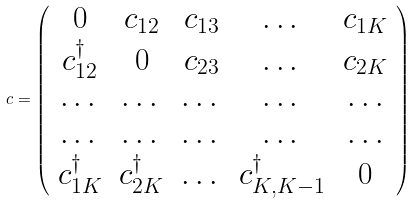<formula> <loc_0><loc_0><loc_500><loc_500>c = \left ( \begin{array} { c c c c c } 0 & c _ { 1 2 } & c _ { 1 3 } & \dots & c _ { 1 K } \\ c ^ { \dagger } _ { 1 2 } & 0 & c _ { 2 3 } & \dots & c _ { 2 K } \\ \dots & \dots & \dots & \dots & \dots \\ \dots & \dots & \dots & \dots & \dots \\ c ^ { \dagger } _ { 1 K } & c ^ { \dagger } _ { 2 K } & \dots & c ^ { \dag } _ { K , K - 1 } & 0 \\ \end{array} \right )</formula> 